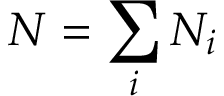<formula> <loc_0><loc_0><loc_500><loc_500>N = \sum _ { i } N _ { i }</formula> 